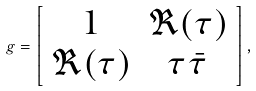Convert formula to latex. <formula><loc_0><loc_0><loc_500><loc_500>g = \left [ \begin{array} { c c } 1 & \Re ( \tau ) \\ \Re ( \tau ) & \tau \bar { \tau } \end{array} \right ] ,</formula> 